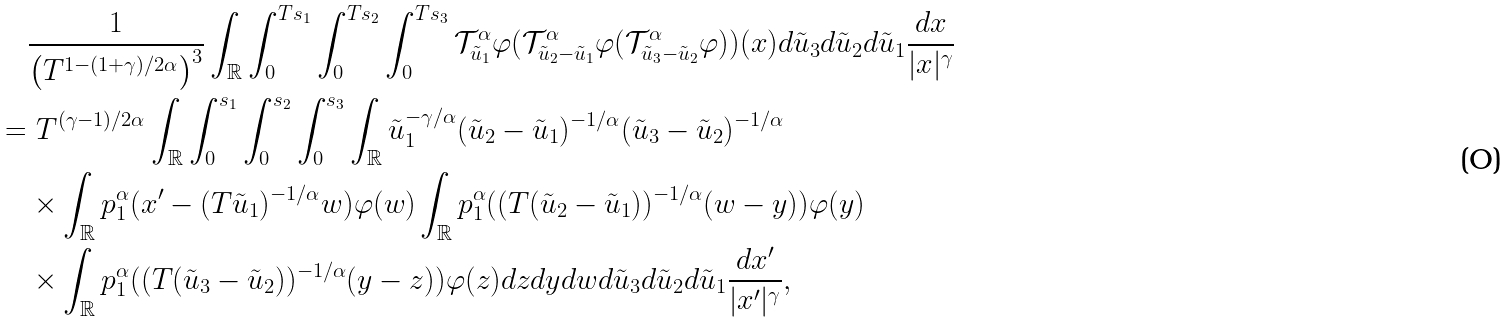Convert formula to latex. <formula><loc_0><loc_0><loc_500><loc_500>& \frac { 1 } { \left ( T ^ { 1 - ( 1 + \gamma ) / 2 \alpha } \right ) ^ { 3 } } \int _ { \mathbb { R } } \int _ { 0 } ^ { T s _ { 1 } } \int _ { 0 } ^ { T s _ { 2 } } \int _ { 0 } ^ { T s _ { 3 } } \mathcal { T } ^ { \alpha } _ { \tilde { u } _ { 1 } } \varphi ( \mathcal { T } ^ { \alpha } _ { \tilde { u } _ { 2 } - \tilde { u } _ { 1 } } \varphi ( \mathcal { T } ^ { \alpha } _ { \tilde { u } _ { 3 } - \tilde { u } _ { 2 } } \varphi ) ) ( x ) d \tilde { u } _ { 3 } d \tilde { u } _ { 2 } d \tilde { u } _ { 1 } \frac { d x } { | x | ^ { \gamma } } \\ = & \ T ^ { ( \gamma - 1 ) / 2 \alpha } \int _ { \mathbb { R } } \int _ { 0 } ^ { s _ { 1 } } \int _ { 0 } ^ { s _ { 2 } } \int _ { 0 } ^ { s _ { 3 } } \int _ { \mathbb { R } } \tilde { u } _ { 1 } ^ { - \gamma / \alpha } ( \tilde { u } _ { 2 } - \tilde { u } _ { 1 } ) ^ { - 1 / \alpha } ( \tilde { u } _ { 3 } - \tilde { u } _ { 2 } ) ^ { - 1 / \alpha } \\ & \times \int _ { \mathbb { R } } p ^ { \alpha } _ { 1 } ( x ^ { \prime } - ( T \tilde { u } _ { 1 } ) ^ { - 1 / \alpha } w ) \varphi ( w ) \int _ { \mathbb { R } } p ^ { \alpha } _ { 1 } ( ( T ( \tilde { u } _ { 2 } - \tilde { u } _ { 1 } ) ) ^ { - 1 / \alpha } ( w - y ) ) \varphi ( y ) \\ & \times \int _ { \mathbb { R } } p ^ { \alpha } _ { 1 } ( ( T ( \tilde { u } _ { 3 } - \tilde { u } _ { 2 } ) ) ^ { - 1 / \alpha } ( y - z ) ) \varphi ( z ) d z d y d w d \tilde { u } _ { 3 } d \tilde { u } _ { 2 } d \tilde { u } _ { 1 } \frac { d x ^ { \prime } } { | x ^ { \prime } | ^ { \gamma } } ,</formula> 